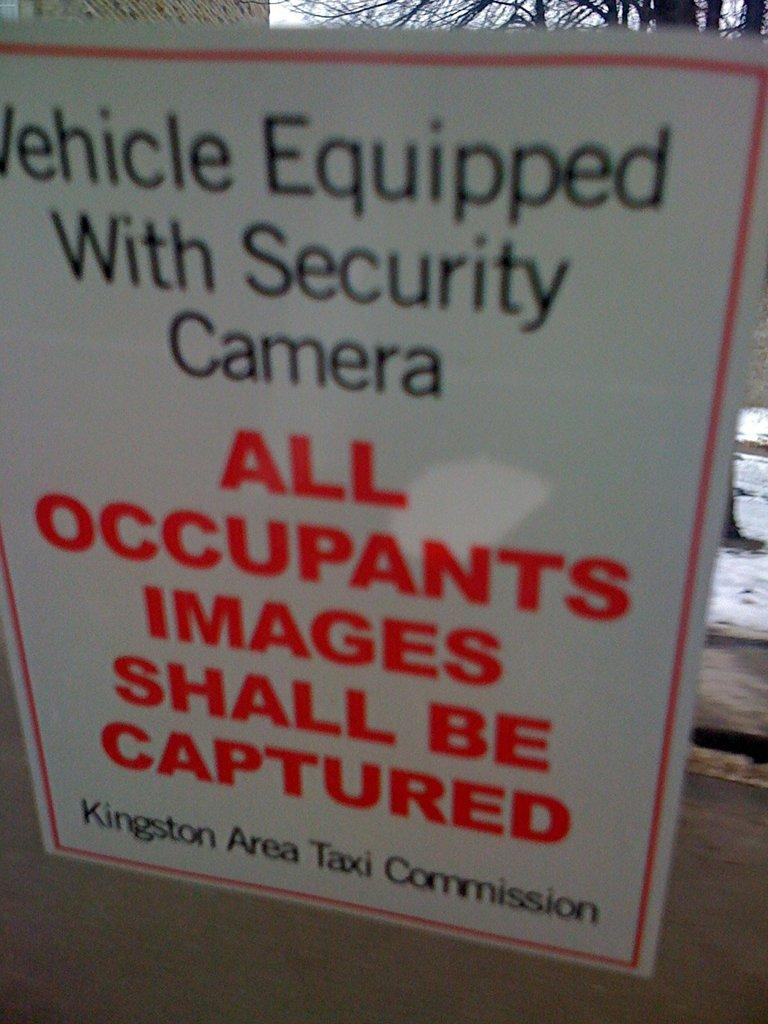<image>
Give a short and clear explanation of the subsequent image. A warning poster that there is a security camera nearby. 